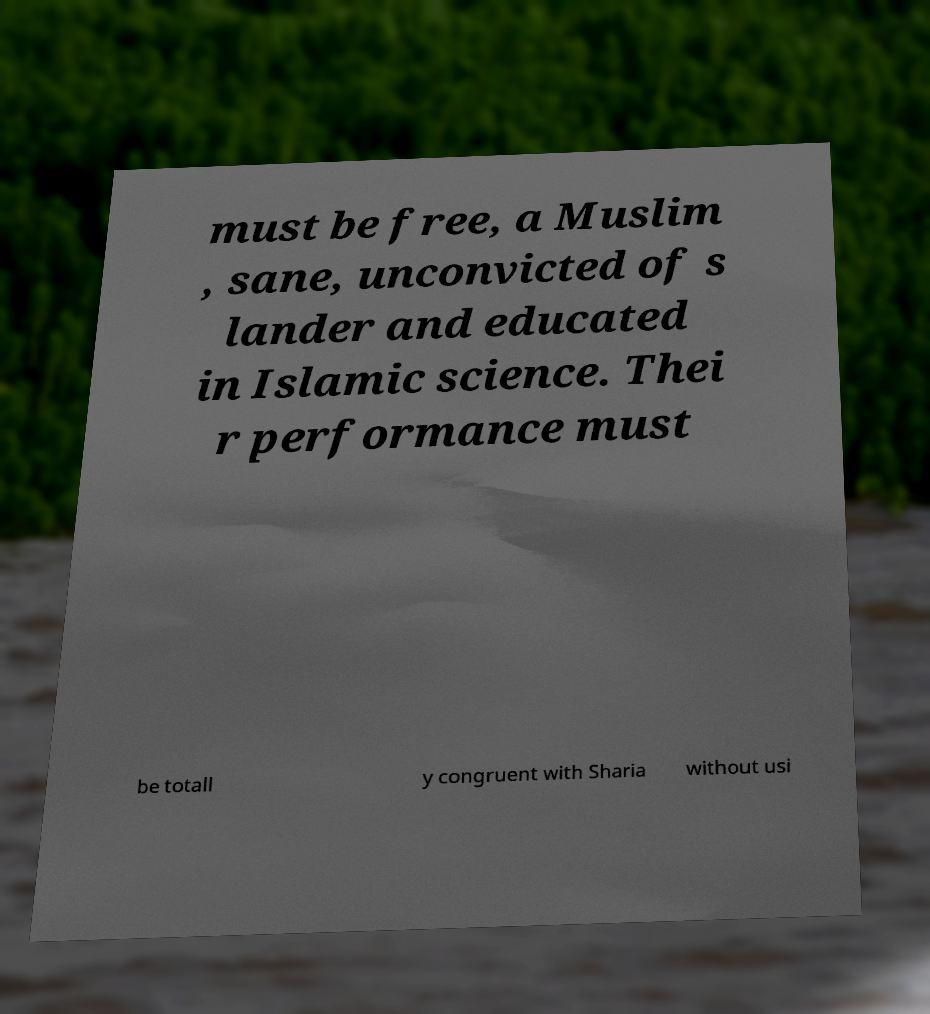Can you read and provide the text displayed in the image?This photo seems to have some interesting text. Can you extract and type it out for me? must be free, a Muslim , sane, unconvicted of s lander and educated in Islamic science. Thei r performance must be totall y congruent with Sharia without usi 